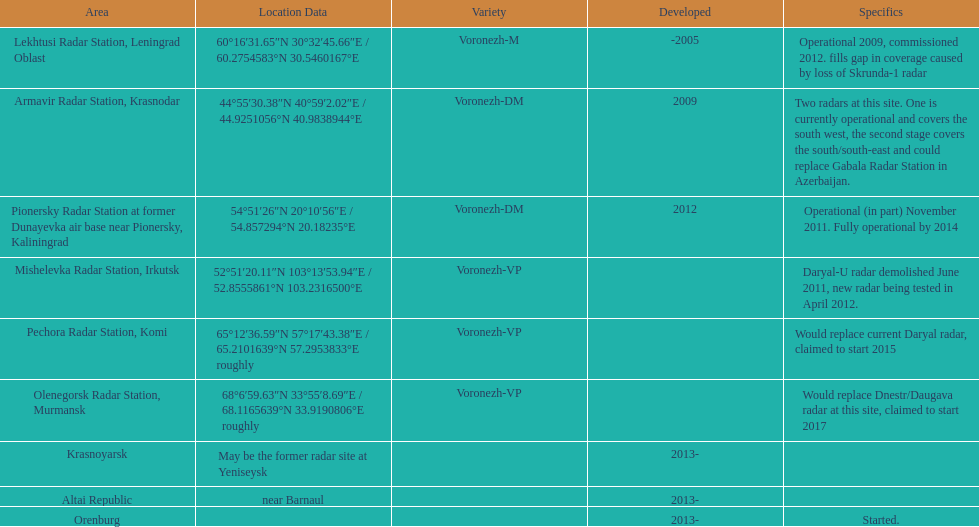Which site has the most radars? Armavir Radar Station, Krasnodar. 